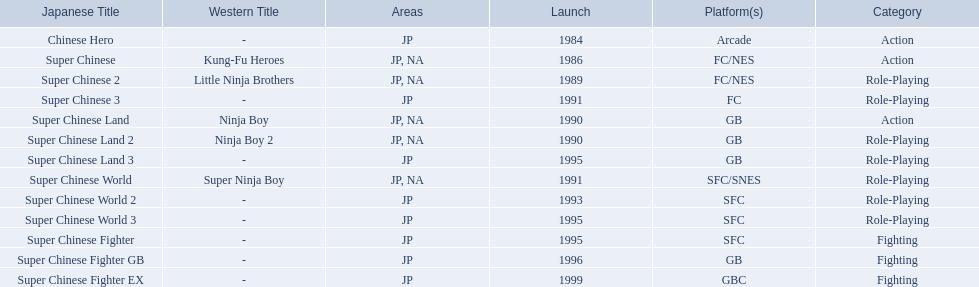What japanese titles were released in the north american (na) region? Super Chinese, Super Chinese 2, Super Chinese Land, Super Chinese Land 2, Super Chinese World. Of those, which one was released most recently? Super Chinese World. 